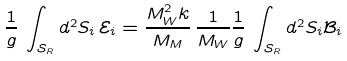<formula> <loc_0><loc_0><loc_500><loc_500>\frac { 1 } { g } \, \int _ { { \mathcal { S } } _ { R } } d ^ { 2 } S _ { i } \, { \mathcal { E } } _ { i } = \frac { M _ { W } ^ { 2 } k } { M _ { M } } \, \frac { 1 } { M _ { W } } \frac { 1 } { g } \, \int _ { { \mathcal { S } } _ { R } } d ^ { 2 } S _ { i } { \mathcal { B } } _ { i }</formula> 